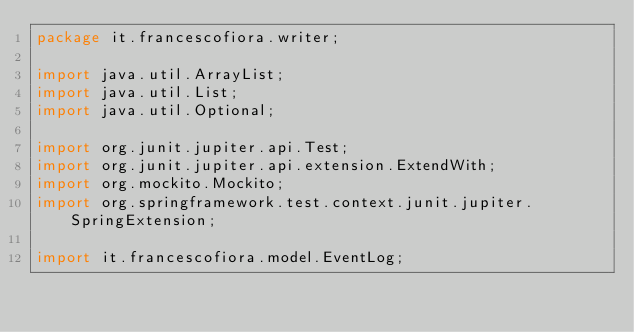Convert code to text. <code><loc_0><loc_0><loc_500><loc_500><_Java_>package it.francescofiora.writer;

import java.util.ArrayList;
import java.util.List;
import java.util.Optional;

import org.junit.jupiter.api.Test;
import org.junit.jupiter.api.extension.ExtendWith;
import org.mockito.Mockito;
import org.springframework.test.context.junit.jupiter.SpringExtension;

import it.francescofiora.model.EventLog;</code> 